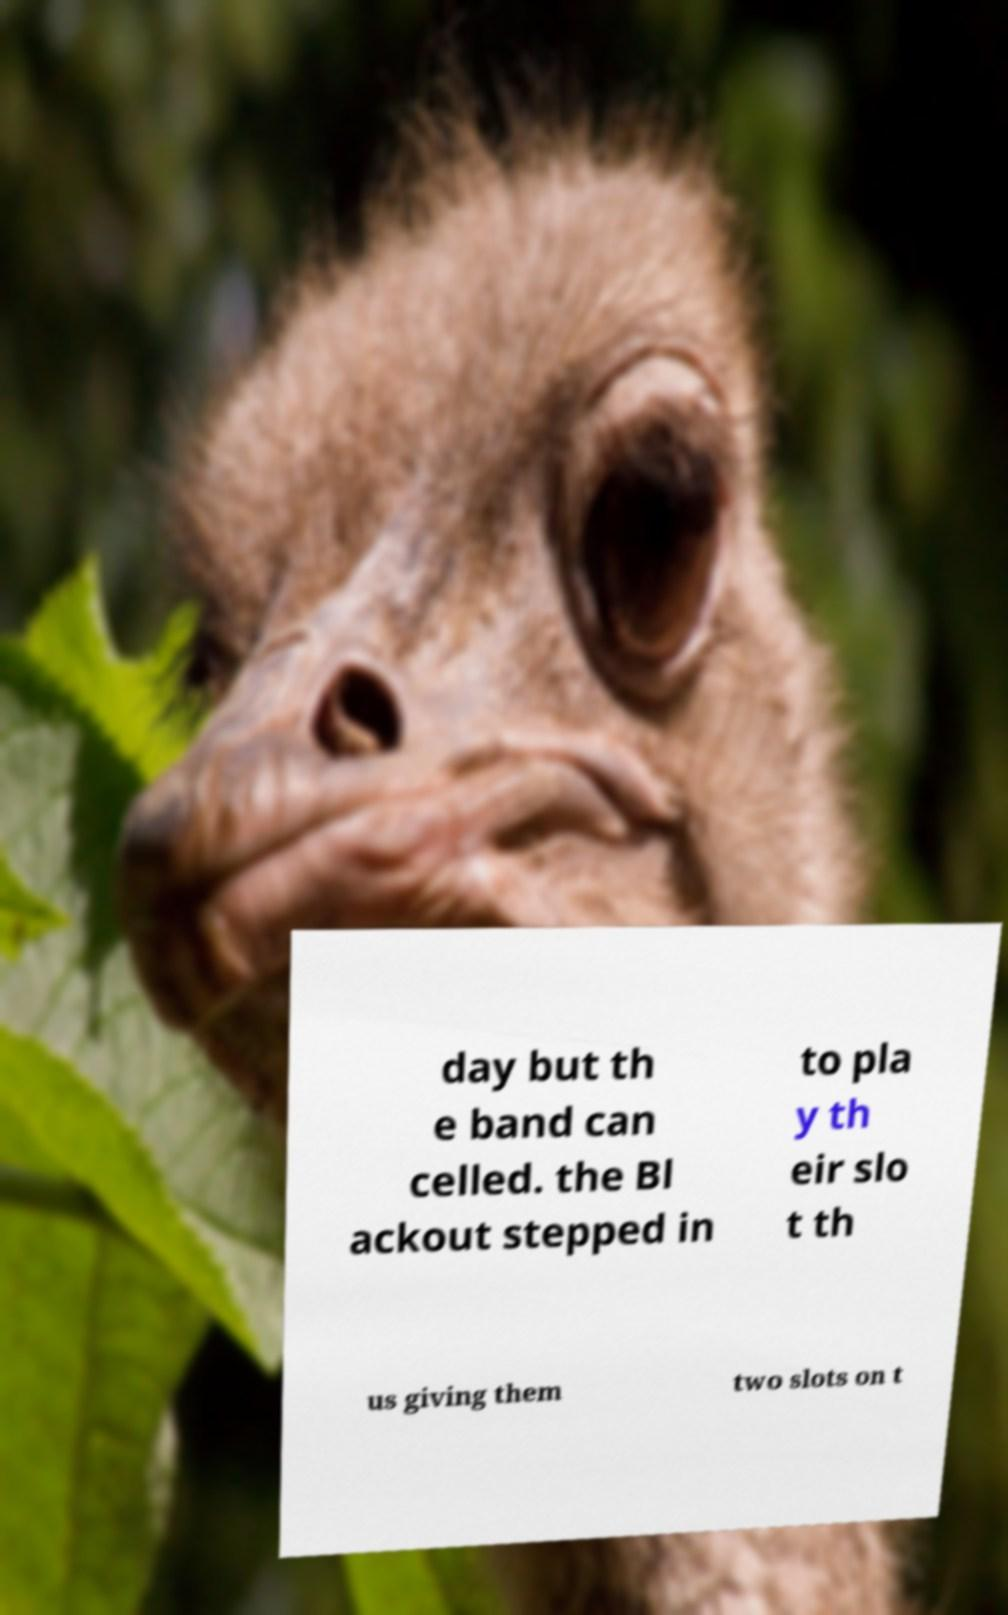There's text embedded in this image that I need extracted. Can you transcribe it verbatim? day but th e band can celled. the Bl ackout stepped in to pla y th eir slo t th us giving them two slots on t 